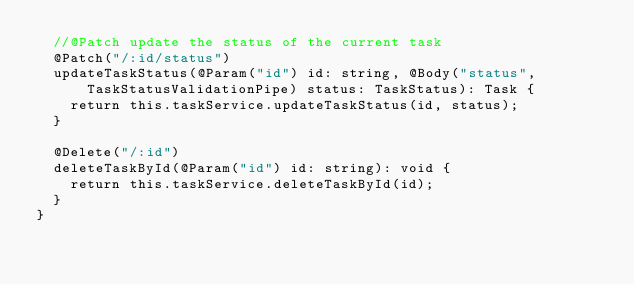Convert code to text. <code><loc_0><loc_0><loc_500><loc_500><_TypeScript_>  //@Patch update the status of the current task
  @Patch("/:id/status")
  updateTaskStatus(@Param("id") id: string, @Body("status", TaskStatusValidationPipe) status: TaskStatus): Task {
    return this.taskService.updateTaskStatus(id, status);
  }

  @Delete("/:id")
  deleteTaskById(@Param("id") id: string): void {
    return this.taskService.deleteTaskById(id);
  }
}
</code> 